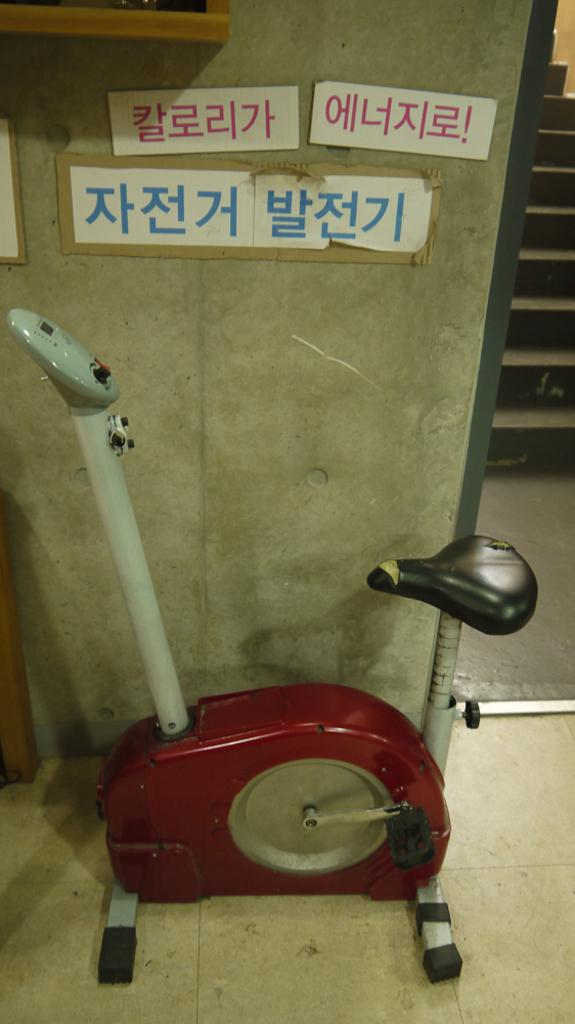<image>
Render a clear and concise summary of the photo. An exercise bike sits under some signs, one of which ends with an exclamation point. 